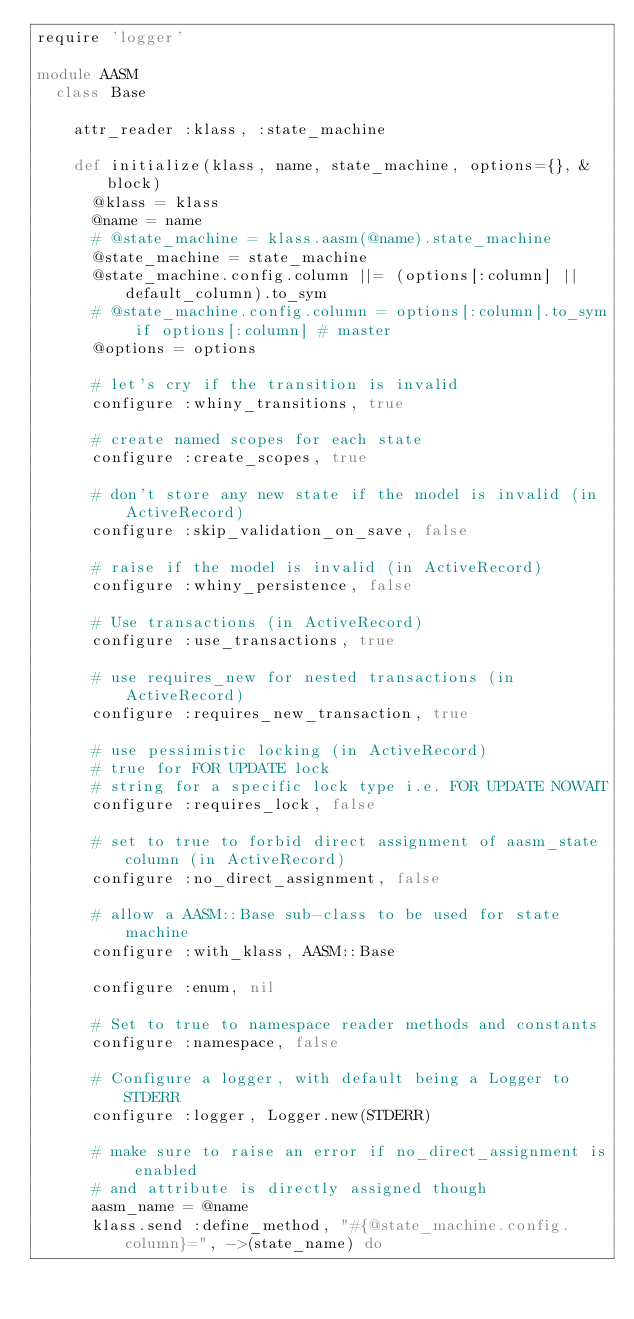<code> <loc_0><loc_0><loc_500><loc_500><_Ruby_>require 'logger'

module AASM
  class Base

    attr_reader :klass, :state_machine

    def initialize(klass, name, state_machine, options={}, &block)
      @klass = klass
      @name = name
      # @state_machine = klass.aasm(@name).state_machine
      @state_machine = state_machine
      @state_machine.config.column ||= (options[:column] || default_column).to_sym
      # @state_machine.config.column = options[:column].to_sym if options[:column] # master
      @options = options

      # let's cry if the transition is invalid
      configure :whiny_transitions, true

      # create named scopes for each state
      configure :create_scopes, true

      # don't store any new state if the model is invalid (in ActiveRecord)
      configure :skip_validation_on_save, false

      # raise if the model is invalid (in ActiveRecord)
      configure :whiny_persistence, false

      # Use transactions (in ActiveRecord)
      configure :use_transactions, true

      # use requires_new for nested transactions (in ActiveRecord)
      configure :requires_new_transaction, true

      # use pessimistic locking (in ActiveRecord)
      # true for FOR UPDATE lock
      # string for a specific lock type i.e. FOR UPDATE NOWAIT
      configure :requires_lock, false

      # set to true to forbid direct assignment of aasm_state column (in ActiveRecord)
      configure :no_direct_assignment, false

      # allow a AASM::Base sub-class to be used for state machine
      configure :with_klass, AASM::Base

      configure :enum, nil

      # Set to true to namespace reader methods and constants
      configure :namespace, false

      # Configure a logger, with default being a Logger to STDERR
      configure :logger, Logger.new(STDERR)

      # make sure to raise an error if no_direct_assignment is enabled
      # and attribute is directly assigned though
      aasm_name = @name
      klass.send :define_method, "#{@state_machine.config.column}=", ->(state_name) do</code> 